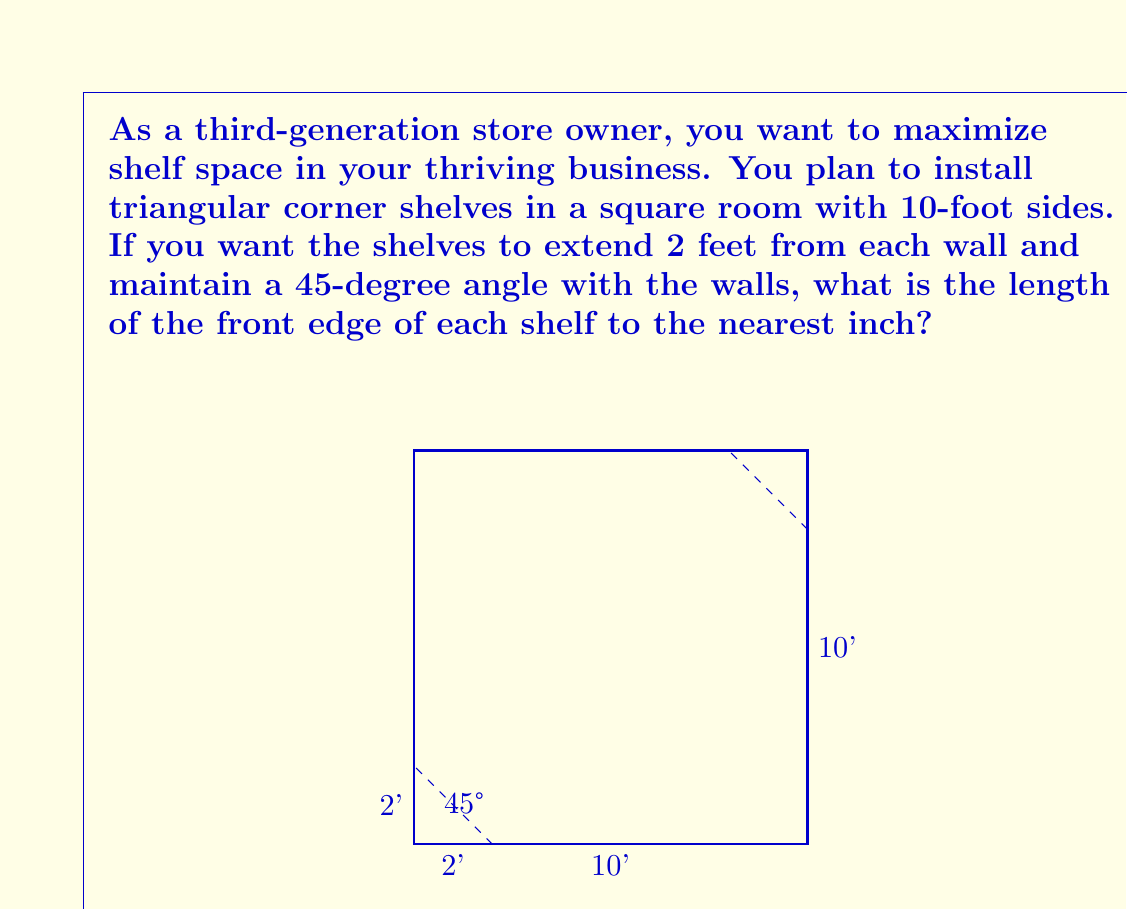Teach me how to tackle this problem. Let's approach this step-by-step:

1) In a right-angled triangle with a 45-degree angle, the two sides adjacent to the right angle are equal. This means the shelf forms an isosceles right triangle.

2) We know that each side of this isosceles right triangle touching the wall is 2 feet long.

3) To find the length of the front edge (hypotenuse), we can use the Pythagorean theorem:

   $$ a^2 + b^2 = c^2 $$

   Where $a$ and $b$ are the sides touching the walls, and $c$ is the front edge.

4) Substituting the known values:

   $$ 2^2 + 2^2 = c^2 $$
   $$ 4 + 4 = c^2 $$
   $$ 8 = c^2 $$

5) Taking the square root of both sides:

   $$ \sqrt{8} = c $$

6) Simplify:
   
   $$ c = \sqrt{8} = 2\sqrt{2} \approx 2.8284 \text{ feet} $$

7) Converting to inches (1 foot = 12 inches):

   $$ 2.8284 \times 12 \approx 33.9408 \text{ inches} $$

8) Rounding to the nearest inch:

   $$ 33.9408 \text{ inches} \approx 34 \text{ inches} $$
Answer: 34 inches 